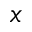<formula> <loc_0><loc_0><loc_500><loc_500>x</formula> 